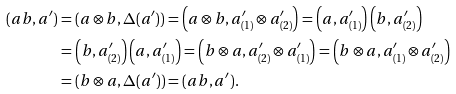<formula> <loc_0><loc_0><loc_500><loc_500>( a b , a ^ { \prime } ) & = ( a \otimes b , \Delta ( a ^ { \prime } ) ) = \left ( a \otimes b , a ^ { \prime } _ { ( 1 ) } \otimes a ^ { \prime } _ { ( 2 ) } \right ) = \left ( a , a ^ { \prime } _ { ( 1 ) } \right ) \left ( b , a ^ { \prime } _ { ( 2 ) } \right ) \\ & = \left ( b , a ^ { \prime } _ { ( 2 ) } \right ) \left ( a , a ^ { \prime } _ { ( 1 ) } \right ) = \left ( b \otimes a , a ^ { \prime } _ { ( 2 ) } \otimes a ^ { \prime } _ { ( 1 ) } \right ) = \left ( b \otimes a , a ^ { \prime } _ { ( 1 ) } \otimes a ^ { \prime } _ { ( 2 ) } \right ) \\ & = ( b \otimes a , \Delta ( a ^ { \prime } ) ) = ( a b , a ^ { \prime } ) .</formula> 